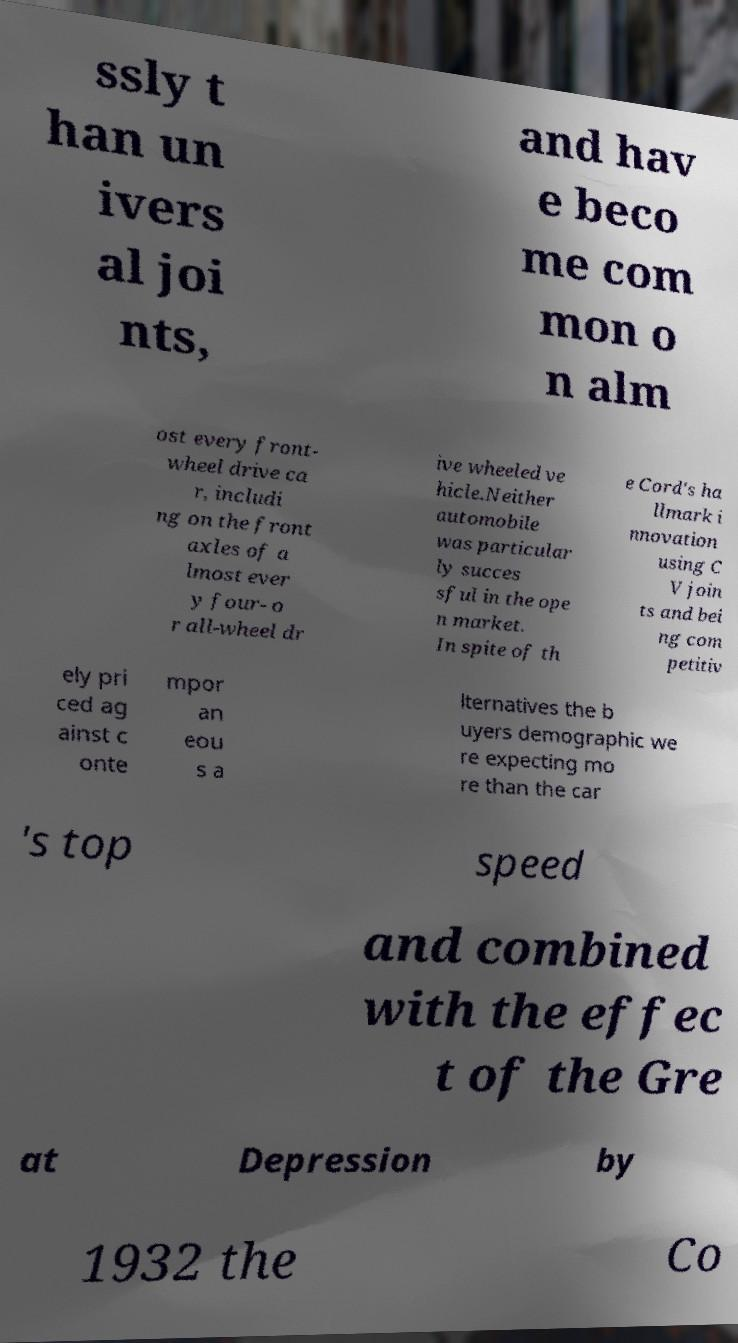Please read and relay the text visible in this image. What does it say? ssly t han un ivers al joi nts, and hav e beco me com mon o n alm ost every front- wheel drive ca r, includi ng on the front axles of a lmost ever y four- o r all-wheel dr ive wheeled ve hicle.Neither automobile was particular ly succes sful in the ope n market. In spite of th e Cord's ha llmark i nnovation using C V join ts and bei ng com petitiv ely pri ced ag ainst c onte mpor an eou s a lternatives the b uyers demographic we re expecting mo re than the car 's top speed and combined with the effec t of the Gre at Depression by 1932 the Co 